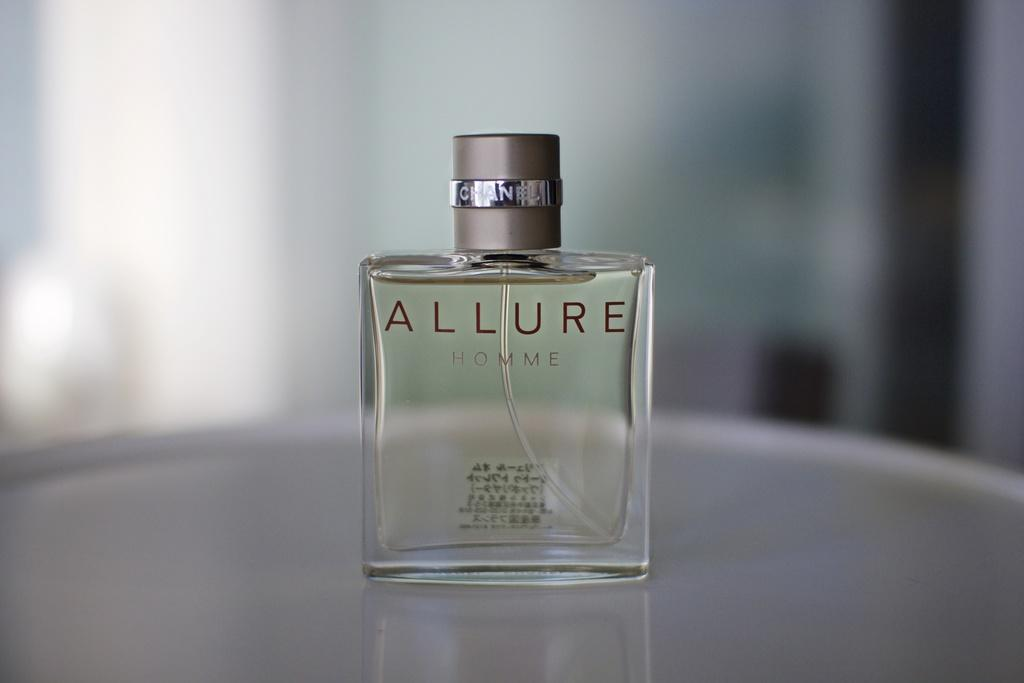<image>
Describe the image concisely. A bottle of perfume sits on the table, the label reads "allure." 